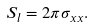<formula> <loc_0><loc_0><loc_500><loc_500>S _ { l } = 2 \pi \sigma _ { x x } .</formula> 